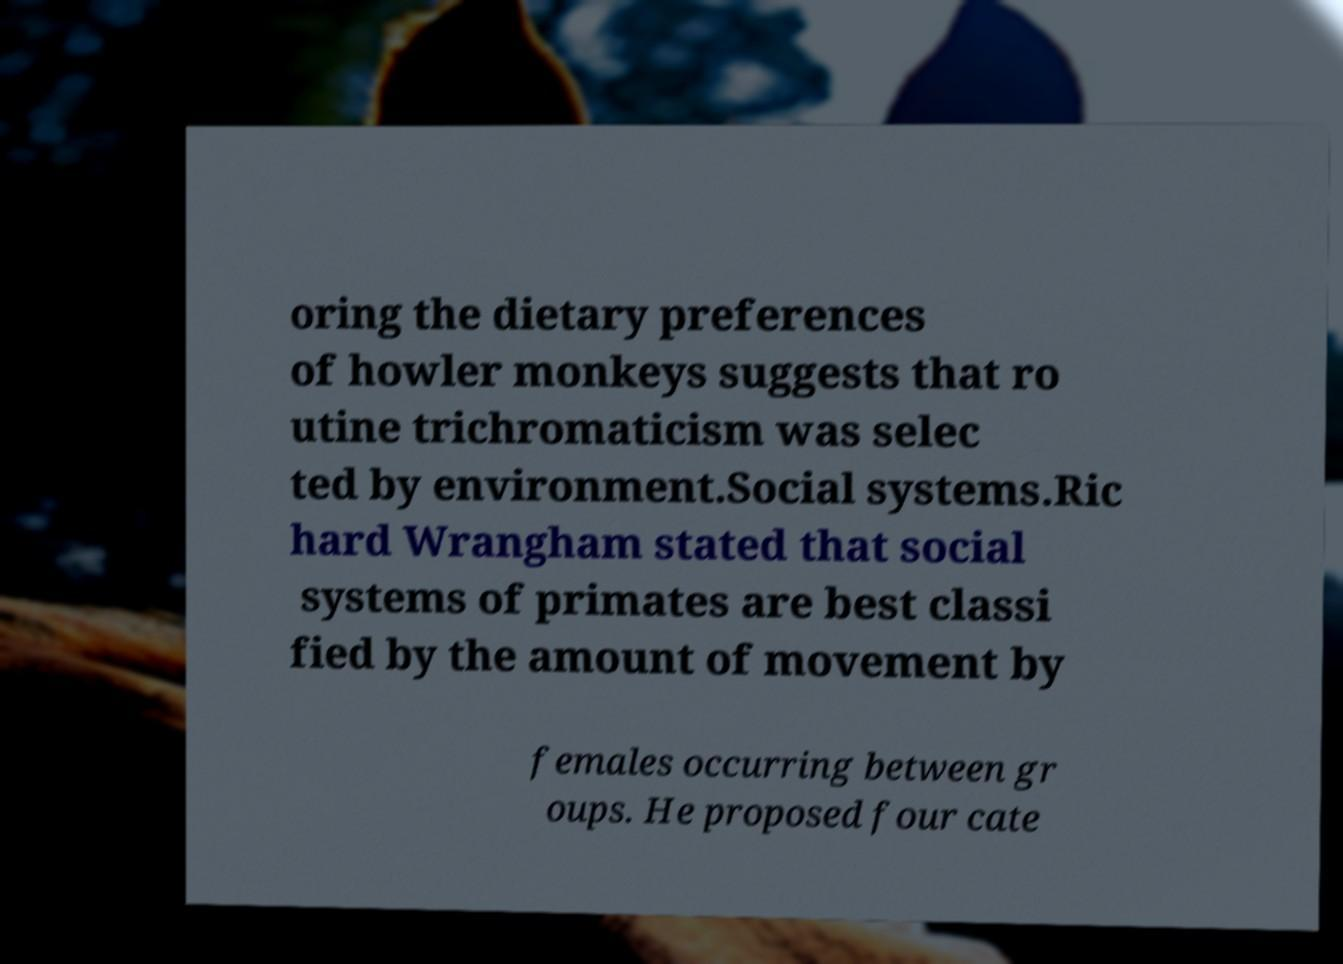Can you accurately transcribe the text from the provided image for me? oring the dietary preferences of howler monkeys suggests that ro utine trichromaticism was selec ted by environment.Social systems.Ric hard Wrangham stated that social systems of primates are best classi fied by the amount of movement by females occurring between gr oups. He proposed four cate 